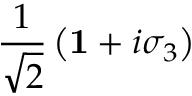<formula> <loc_0><loc_0><loc_500><loc_500>\frac { 1 } { \sqrt { 2 } } \left ( { 1 } + i \sigma _ { 3 } \right )</formula> 